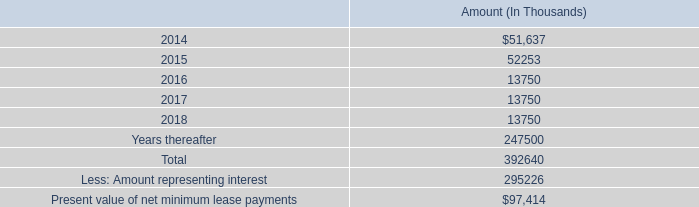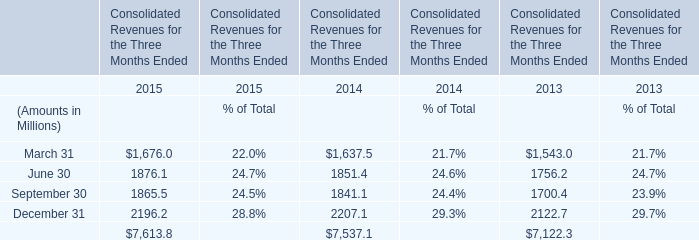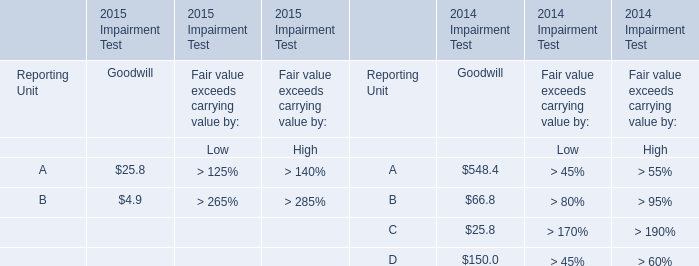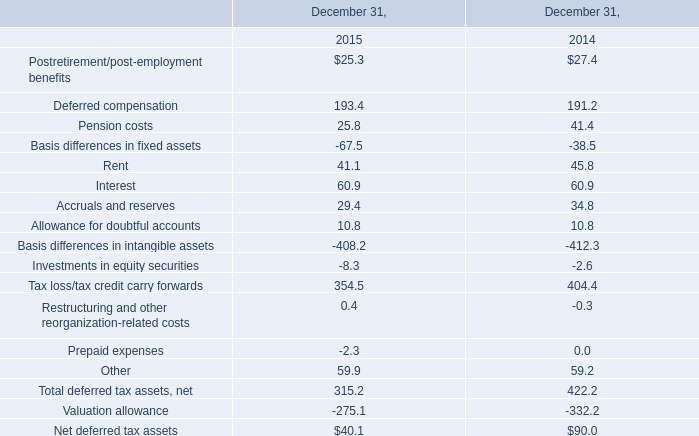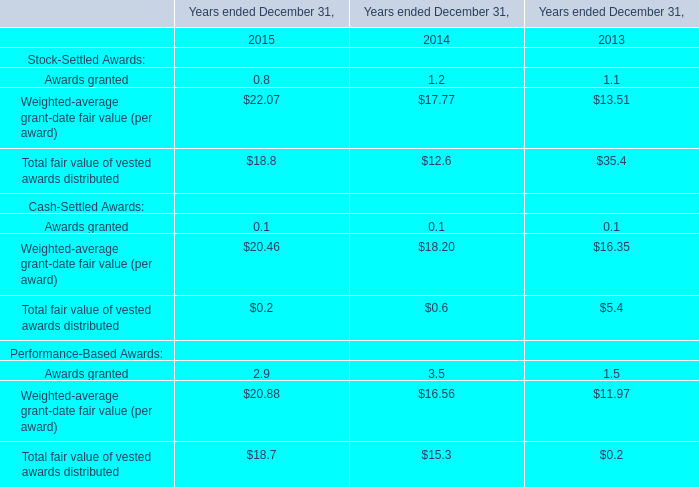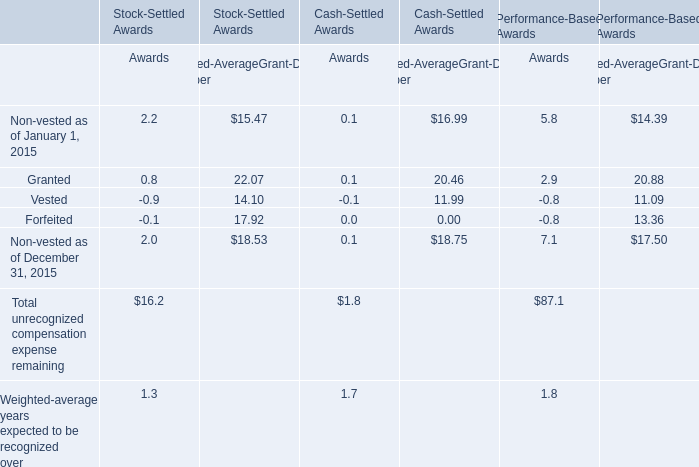What will the Total fair value of vested awards distributed for Stock-Settled Awards reach in 2016 if it continues to grow at its current rate? 
Computations: (18.8 * (1 + ((18.8 - 12.6) / 12.6)))
Answer: 28.05079. 